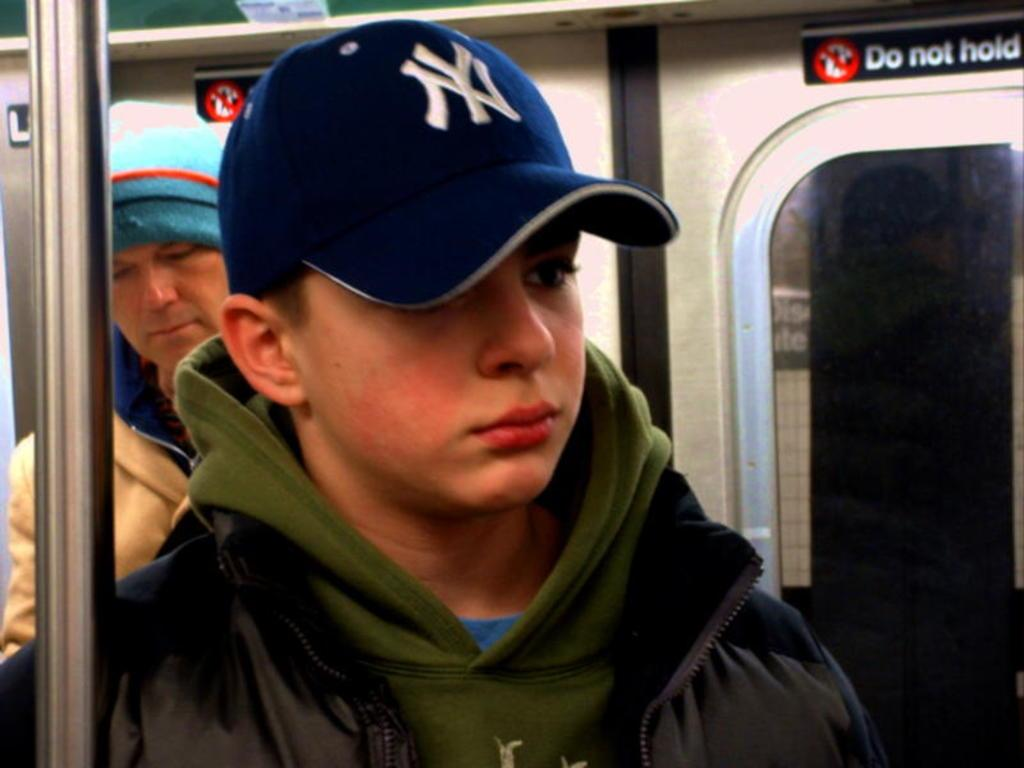What type of setting is depicted in the image? The image is an inner view of a vehicle. How many people are present in the vehicle? There are two men in the vehicle. What object can be seen inside the vehicle? There is a metal pole in the vehicle. What feature allows for visibility from the backside of the vehicle? There is a window on the backside of the vehicle. What can be seen on the boards with text on the backside of the vehicle? The boards with text on the backside of the vehicle have text on them. How many stars can be seen in the image? There are no stars visible in the image. 